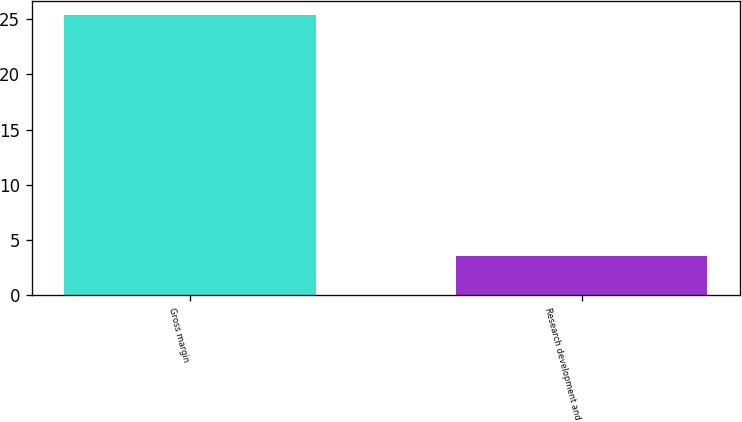Convert chart to OTSL. <chart><loc_0><loc_0><loc_500><loc_500><bar_chart><fcel>Gross margin<fcel>Research development and<nl><fcel>25.4<fcel>3.6<nl></chart> 